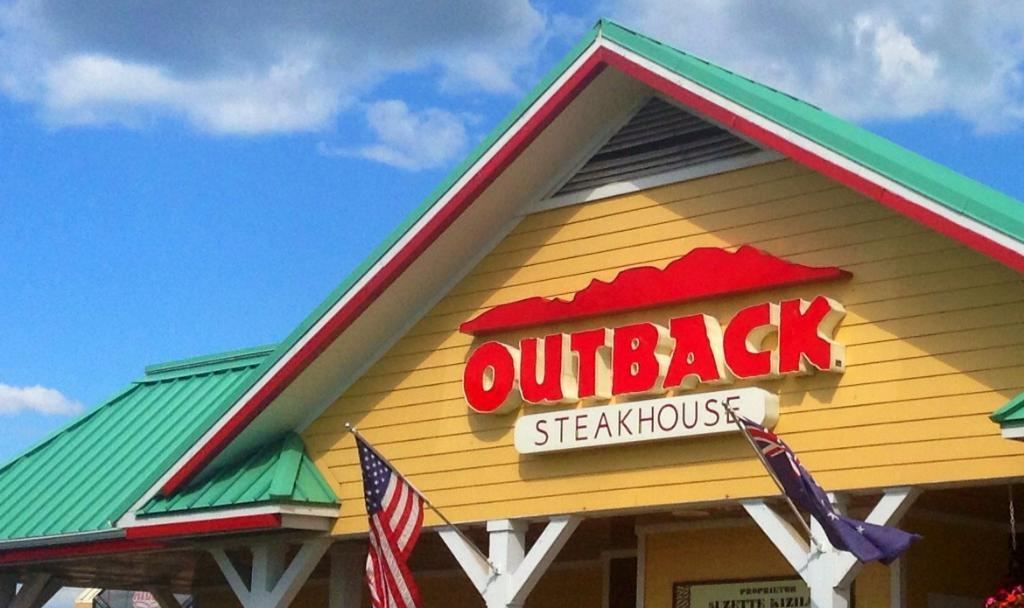What structure is the main subject of the image? There is a building in the image. What can be seen in the sky behind the building? There are clouds in the sky behind the building. What part of the natural environment is visible in the image? The sky is visible in the image. How many flags are present on the building? There are two flags on the building. What type of chain can be seen connecting the two flags on the building? There is no chain connecting the two flags on the building in the image. How many cherries are on top of the building in the image? There are no cherries present on top of the building in the image. 